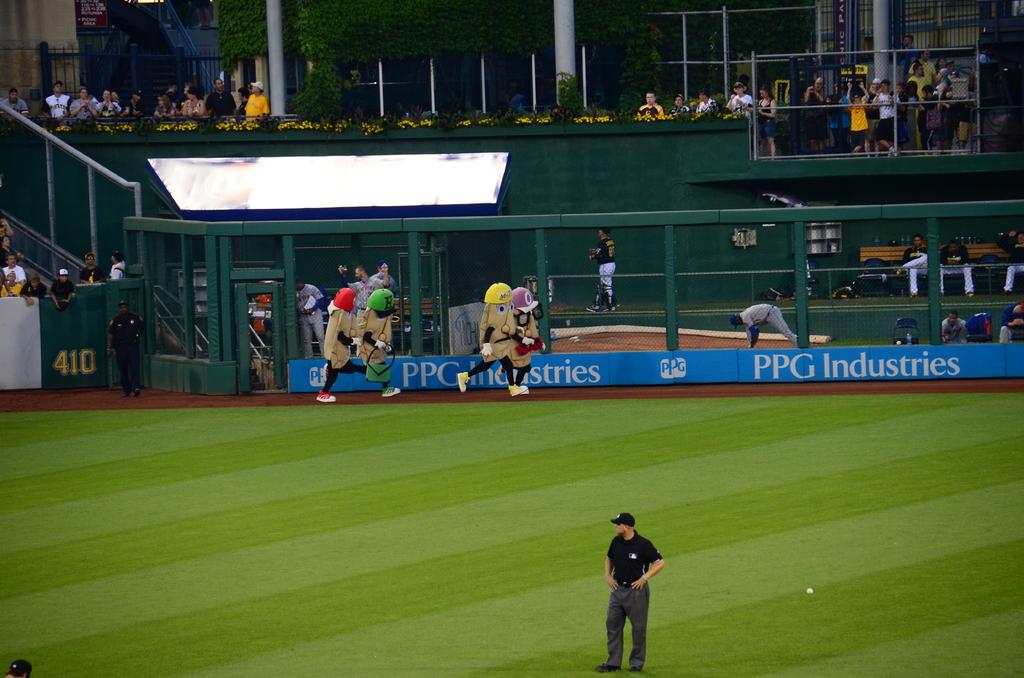What type of industries is written on the back wall?
Your response must be concise. Ppg. Who sponsors this ballpark?
Offer a terse response. Ppg industries. 